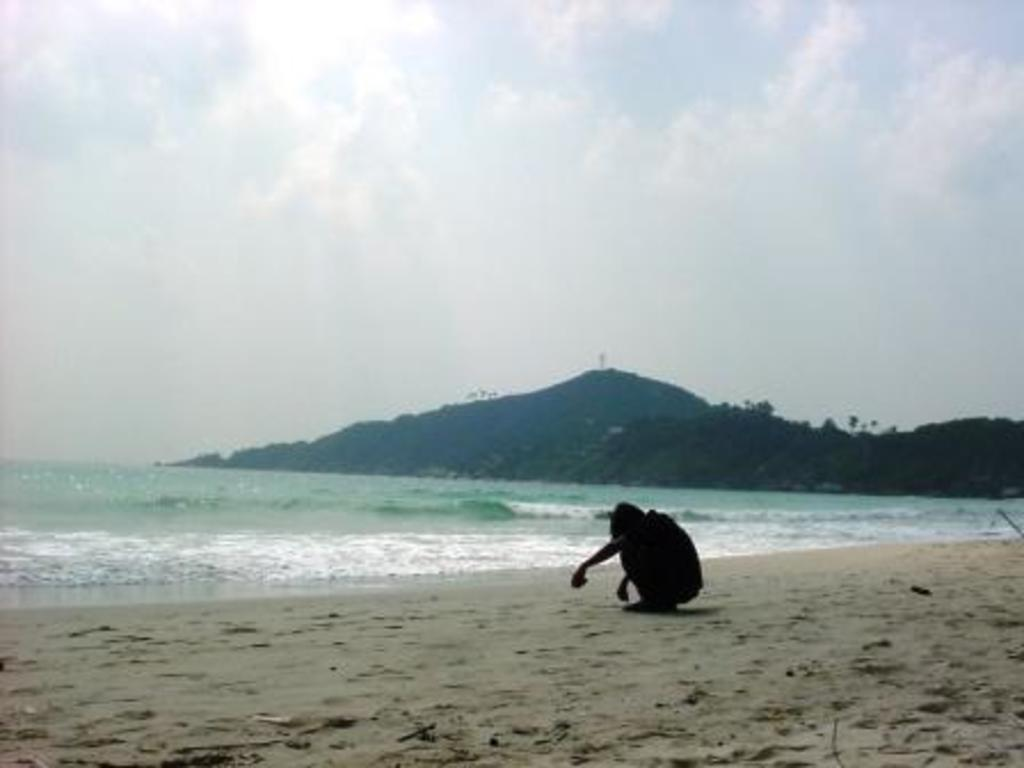Who or what is present in the image? There is a person in the image. What type of terrain can be seen in the image? There is sand and water visible in the image. What can be seen in the distance in the image? There are mountains in the background of the image. What is visible above the mountains in the image? The sky is visible in the background of the image. What grade did the person receive on their recent account in the image? There is no information about grades or accounts in the image; it only shows a person in a sandy and watery environment with mountains and sky in the background. 